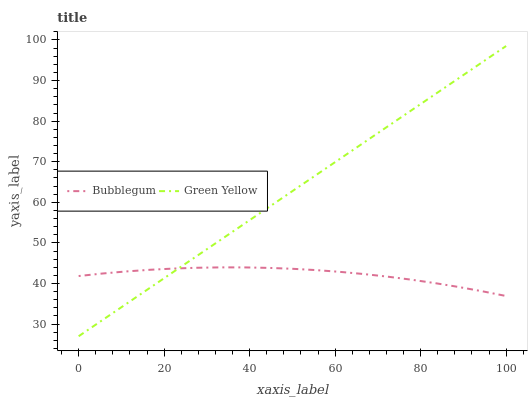Does Bubblegum have the minimum area under the curve?
Answer yes or no. Yes. Does Green Yellow have the maximum area under the curve?
Answer yes or no. Yes. Does Bubblegum have the maximum area under the curve?
Answer yes or no. No. Is Green Yellow the smoothest?
Answer yes or no. Yes. Is Bubblegum the roughest?
Answer yes or no. Yes. Is Bubblegum the smoothest?
Answer yes or no. No. Does Green Yellow have the lowest value?
Answer yes or no. Yes. Does Bubblegum have the lowest value?
Answer yes or no. No. Does Green Yellow have the highest value?
Answer yes or no. Yes. Does Bubblegum have the highest value?
Answer yes or no. No. Does Bubblegum intersect Green Yellow?
Answer yes or no. Yes. Is Bubblegum less than Green Yellow?
Answer yes or no. No. Is Bubblegum greater than Green Yellow?
Answer yes or no. No. 